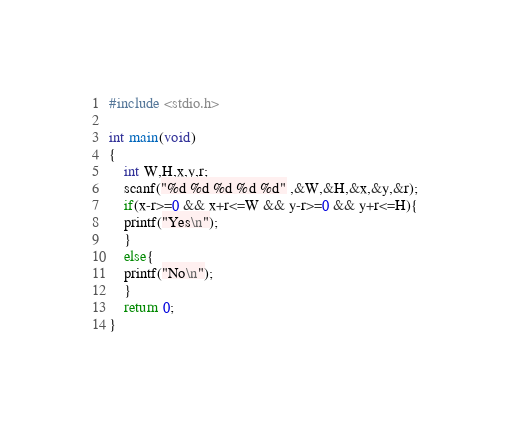<code> <loc_0><loc_0><loc_500><loc_500><_C_>#include <stdio.h>

int main(void)
{
	int W,H,x,y,r;
	scanf("%d %d %d %d %d" ,&W,&H,&x,&y,&r);
	if(x-r>=0 && x+r<=W && y-r>=0 && y+r<=H){
	printf("Yes\n");
	}
	else{
	printf("No\n");
	}
	return 0;
}</code> 